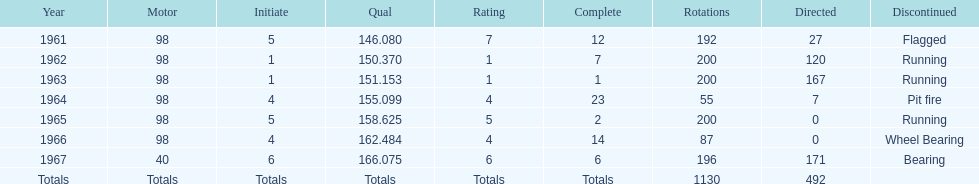What was his best finish before his first win? 7. 